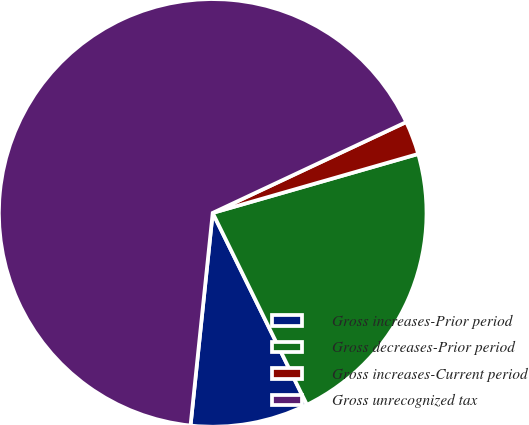<chart> <loc_0><loc_0><loc_500><loc_500><pie_chart><fcel>Gross increases-Prior period<fcel>Gross decreases-Prior period<fcel>Gross increases-Current period<fcel>Gross unrecognized tax<nl><fcel>8.92%<fcel>22.18%<fcel>2.54%<fcel>66.36%<nl></chart> 